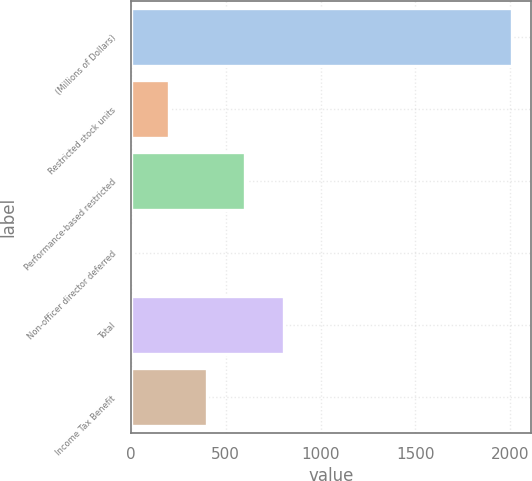<chart> <loc_0><loc_0><loc_500><loc_500><bar_chart><fcel>(Millions of Dollars)<fcel>Restricted stock units<fcel>Performance-based restricted<fcel>Non-officer director deferred<fcel>Total<fcel>Income Tax Benefit<nl><fcel>2011<fcel>202<fcel>604<fcel>1<fcel>805<fcel>403<nl></chart> 